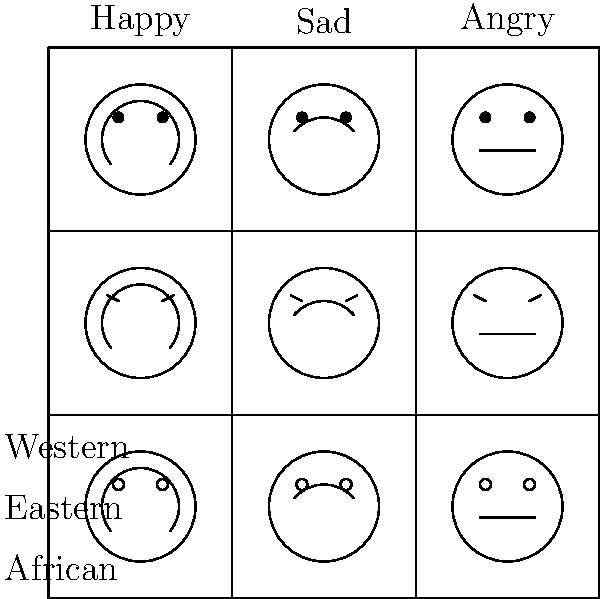Analyze the grid of facial expressions across different cultural contexts. Which cultural group appears to express anger most subtly, and how might this impact cross-cultural communication in a therapeutic setting? To answer this question, we need to examine the facial expressions for anger across the three cultural groups represented in the grid:

1. Western culture (top row):
   - The angry expression is depicted with a pronounced downward curve of the mouth.
   - This represents a more overt display of anger.

2. Eastern culture (middle row):
   - The angry expression is shown with a straight line for the mouth.
   - This indicates a more restrained or neutral expression of anger.

3. African culture (bottom row):
   - The angry expression is similar to the Western one, with a clear downward curve of the mouth.
   - This also represents a more overt display of anger.

Comparing these representations, we can observe that the Eastern cultural group appears to express anger most subtly, with a neutral mouth expression rather than a pronounced frown.

The impact on cross-cultural communication in a therapeutic setting could be significant:

1. Misinterpretation: A therapist from a Western or African background might misinterpret the subtle anger expression of an Eastern client as neutral or non-angry.

2. Cultural sensitivity: Therapists need to be aware of these cultural differences to accurately assess their clients' emotional states.

3. Adjustment of therapeutic approach: Understanding these subtle expressions may require therapists to ask more direct questions about emotions or use other assessment tools to gauge anger in Eastern clients.

4. Building rapport: Recognizing and respecting these cultural differences in emotional expression can help build trust and understanding between therapist and client.

5. Emotional regulation: Therapists might need to consider cultural norms around emotional expression when discussing anger management strategies.

6. Non-verbal communication: This subtlety in anger expression might extend to other emotions, emphasizing the importance of paying close attention to non-verbal cues in cross-cultural therapy.
Answer: Eastern culture; potential misinterpretation of emotions, requiring cultural sensitivity and adjusted assessment techniques in therapy. 